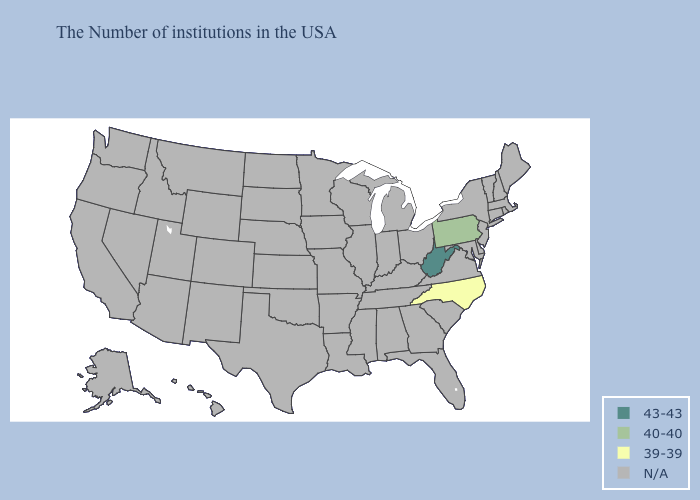What is the value of Virginia?
Concise answer only. N/A. What is the value of Vermont?
Keep it brief. N/A. Does Pennsylvania have the highest value in the USA?
Keep it brief. No. What is the value of North Carolina?
Short answer required. 39-39. What is the value of Idaho?
Concise answer only. N/A. Does West Virginia have the highest value in the USA?
Give a very brief answer. Yes. Name the states that have a value in the range 43-43?
Be succinct. West Virginia. Name the states that have a value in the range N/A?
Write a very short answer. Maine, Massachusetts, Rhode Island, New Hampshire, Vermont, Connecticut, New York, New Jersey, Delaware, Maryland, Virginia, South Carolina, Ohio, Florida, Georgia, Michigan, Kentucky, Indiana, Alabama, Tennessee, Wisconsin, Illinois, Mississippi, Louisiana, Missouri, Arkansas, Minnesota, Iowa, Kansas, Nebraska, Oklahoma, Texas, South Dakota, North Dakota, Wyoming, Colorado, New Mexico, Utah, Montana, Arizona, Idaho, Nevada, California, Washington, Oregon, Alaska, Hawaii. How many symbols are there in the legend?
Be succinct. 4. What is the value of West Virginia?
Give a very brief answer. 43-43. Does the first symbol in the legend represent the smallest category?
Quick response, please. No. Name the states that have a value in the range N/A?
Short answer required. Maine, Massachusetts, Rhode Island, New Hampshire, Vermont, Connecticut, New York, New Jersey, Delaware, Maryland, Virginia, South Carolina, Ohio, Florida, Georgia, Michigan, Kentucky, Indiana, Alabama, Tennessee, Wisconsin, Illinois, Mississippi, Louisiana, Missouri, Arkansas, Minnesota, Iowa, Kansas, Nebraska, Oklahoma, Texas, South Dakota, North Dakota, Wyoming, Colorado, New Mexico, Utah, Montana, Arizona, Idaho, Nevada, California, Washington, Oregon, Alaska, Hawaii. 